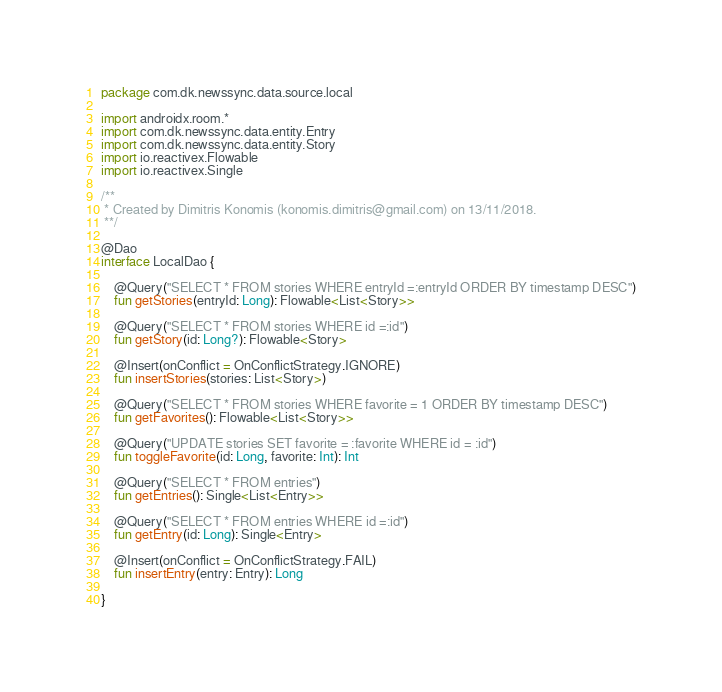Convert code to text. <code><loc_0><loc_0><loc_500><loc_500><_Kotlin_>package com.dk.newssync.data.source.local

import androidx.room.*
import com.dk.newssync.data.entity.Entry
import com.dk.newssync.data.entity.Story
import io.reactivex.Flowable
import io.reactivex.Single

/**
 * Created by Dimitris Konomis (konomis.dimitris@gmail.com) on 13/11/2018.
 **/

@Dao
interface LocalDao {

    @Query("SELECT * FROM stories WHERE entryId =:entryId ORDER BY timestamp DESC")
    fun getStories(entryId: Long): Flowable<List<Story>>

    @Query("SELECT * FROM stories WHERE id =:id")
    fun getStory(id: Long?): Flowable<Story>

    @Insert(onConflict = OnConflictStrategy.IGNORE)
    fun insertStories(stories: List<Story>)

    @Query("SELECT * FROM stories WHERE favorite = 1 ORDER BY timestamp DESC")
    fun getFavorites(): Flowable<List<Story>>

    @Query("UPDATE stories SET favorite = :favorite WHERE id = :id")
    fun toggleFavorite(id: Long, favorite: Int): Int

    @Query("SELECT * FROM entries")
    fun getEntries(): Single<List<Entry>>

    @Query("SELECT * FROM entries WHERE id =:id")
    fun getEntry(id: Long): Single<Entry>

    @Insert(onConflict = OnConflictStrategy.FAIL)
    fun insertEntry(entry: Entry): Long

}</code> 